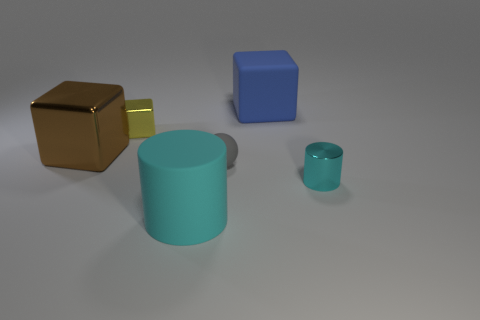Can you describe the arrangement and the colors of the objects presented in a creative way? Certainly! Imagine a serene landscape of solitude where geometric forms dwell in harmony. Foremost, a large brown cube stands as an ancient monolith, its metallic sheen hinting at untold stories. A small sun-like cube, gleaming with a golden aura, peeks from behind this monument, infusing the scene with a drop of warmth. Nearby, a resolute cyan cylinder stands tall, its stature unbowed by the gentle shadows. In its quaint presence, a miniature counterpart mirrors its form in a softer whisper of unity. Finally, a square prism clothed in the tranquil azure of a twilight sky completes the tableau, its position a respectful nod to the congregation of shapes. 